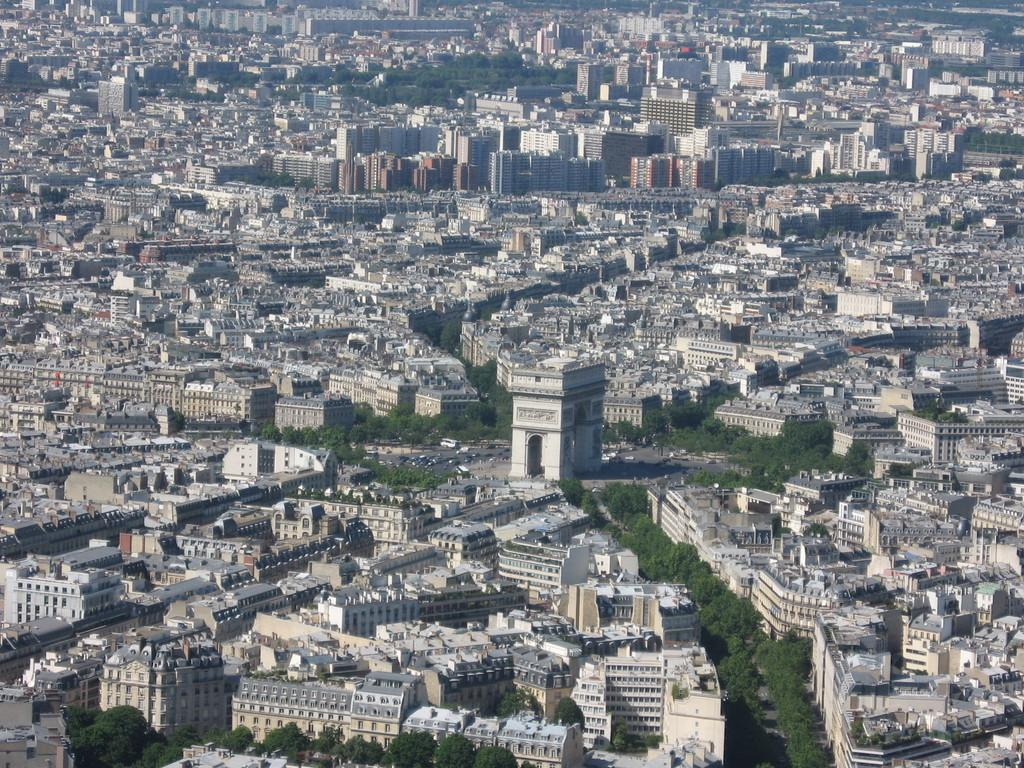What type of view is shown in the image? The image is an aerial view. What structures can be seen in the image? There are buildings and skyscrapers in the image. What natural elements are present in the image? There are trees in the image. What man-made elements are present in the image? There are roads in the image. How many sheep can be seen grazing in the image? There are no sheep present in the image. What type of sticks are used to support the trees in the image? The image does not show any sticks used to support the trees, nor does it show any trees that require support. 